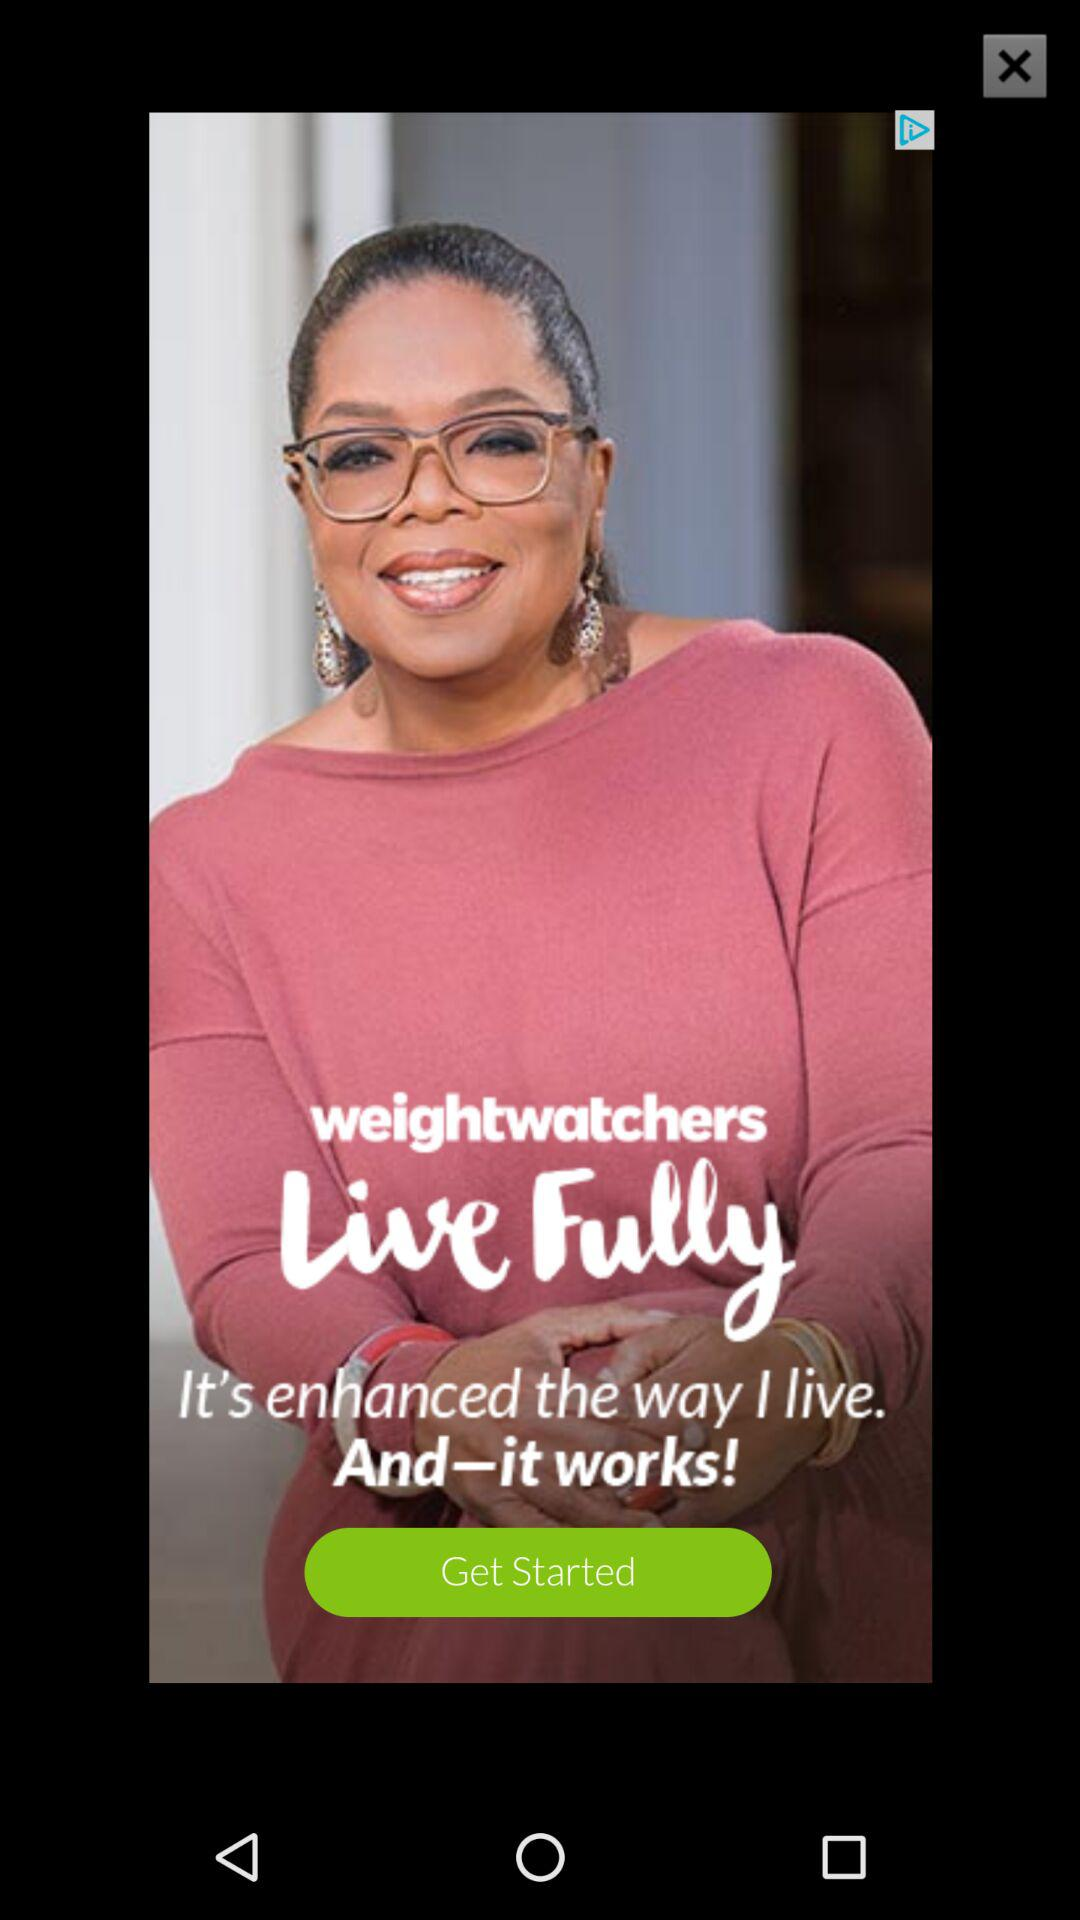What is the name of the application? The name of the application is "weightwatchers". 